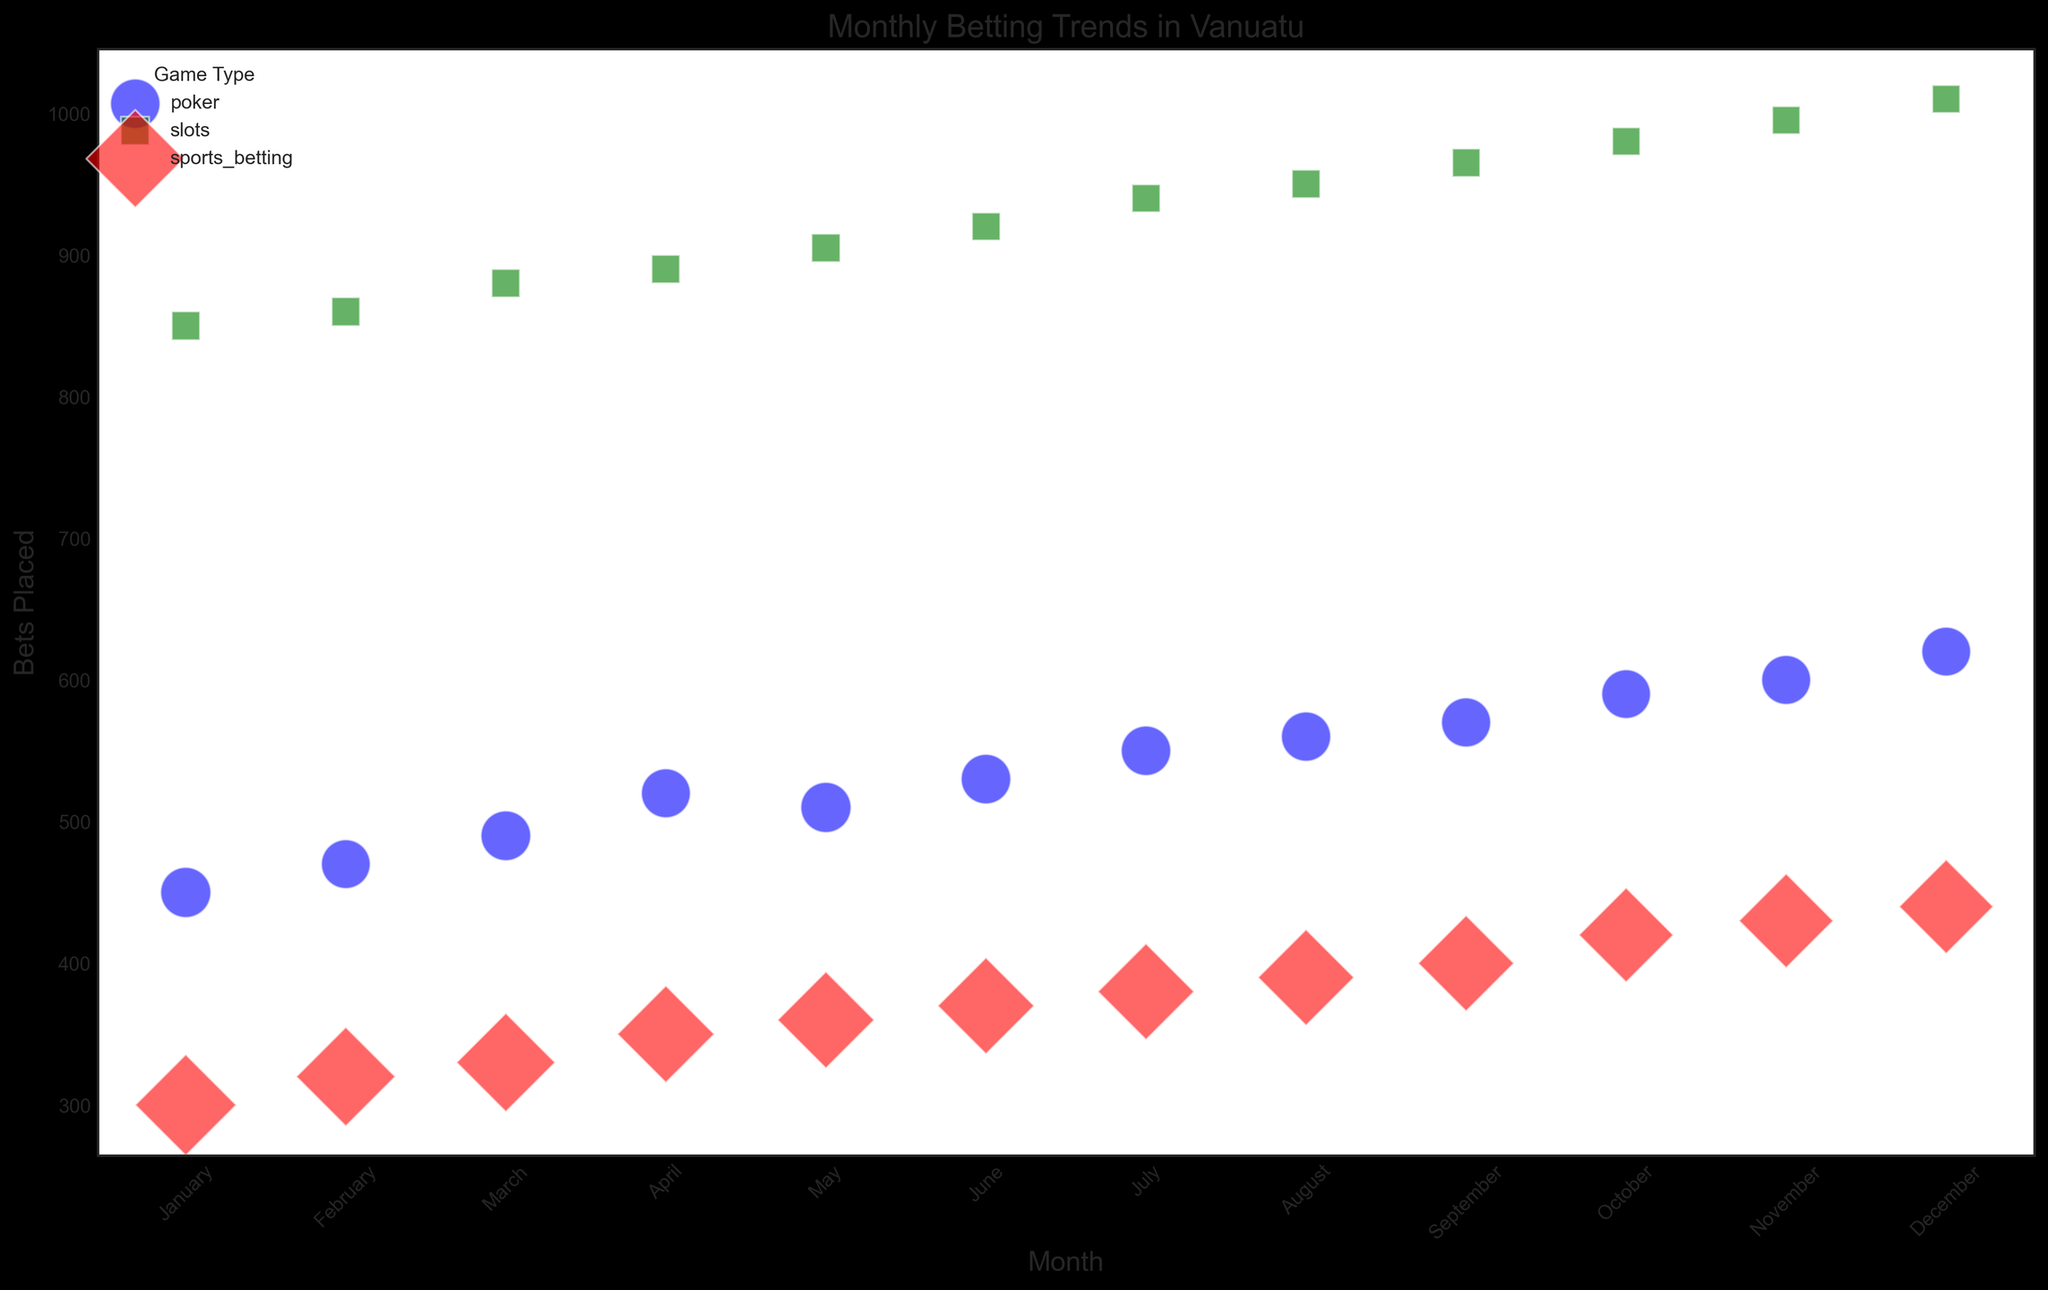How does the number of bets placed in poker compare between January and December? Poker bets placed in January are 450, while in December, it is 620. By comparing these numbers, you can see there is an increase.
Answer: December's poker bets are higher What is the average bet size for slots in July? The average bet size for slots in July, as shown by the bubble size, is the size of the bubble representing average bets. By reviewing the data, we see it is 10.2
Answer: 10.2 Which game type experienced the highest number of bets placed in any month, and what month was it? Reviewing the chart and identifying the peak bubble size for the bet count, we find it is for slots in December with a bet count of 1010.
Answer: Slots in December Which game type has the smallest average bet size, and which month does it occur? Examining the smallest bubbles, slots have the smallest average bet size consistently across all months. From the data, we see it is 10.0 in November and December.
Answer: Slots in November/December Are there any months where poker bets placed were less than 500? If so, which ones? By looking at the size of the poker bubbles along the Y-axis, several months have values below 500. Specifically, January, February, March, and April.
Answer: January, February, March, and April How do average bet sizes compare between poker and sports betting in March? Comparing the bubble sizes, sports betting bubbles are generally larger than poker bubbles indicating higher average bet sizes. For March, poker is 32.7, and sports betting is 63.6. Therefore, sports betting average bets are larger in March.
Answer: Sports betting is larger Which game type shows a consistent increase in bets placed every month? Observing the trend lines for each game type, sports betting shows a clear and steady increase in bets placed each month.
Answer: Sports betting Compare the change in bets placed for poker between July and August with the change for slots in the same months. Analyzing the change for poker from July (550) to August (560) and slots from July (940) to August (950), both increases are observed but the change is 10 bets for slots and 10 for poker, thus the changes are the same in magnitude but reflect different scales and contexts.
Answer: Both increase by 10 Which month had the highest total bets placed across all games, and what is that total? Summing up the bets for each game type across months and identifying the peak, December shows highest with poker (620), slots (1010), and sports betting (440). The total is 2070.
Answer: December with 2070 What can be inferred about the trend in average bets placed on sports betting over the year? Looking at the bubble sizes for sports betting, which shrink over time, it suggests the average bet size is gradually decreasing throughout the year.
Answer: Decreasing trend 